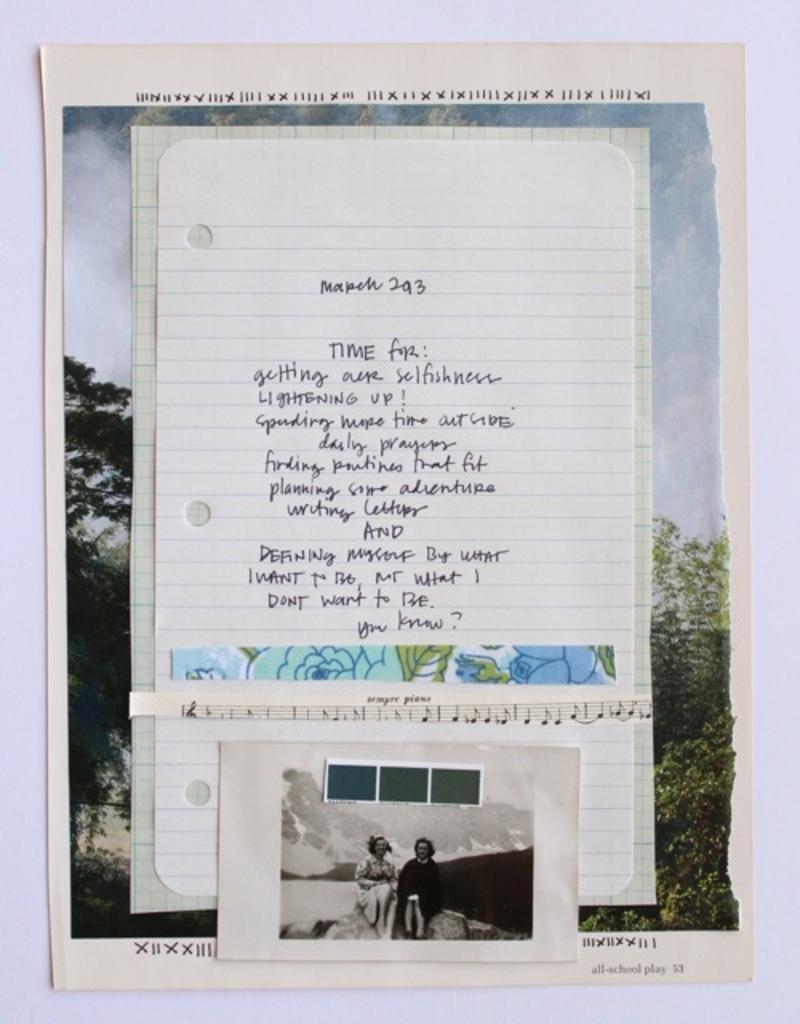Is this poem?
Your response must be concise. Yes. What page number is shown on bottom right corner?
Offer a terse response. 53. 